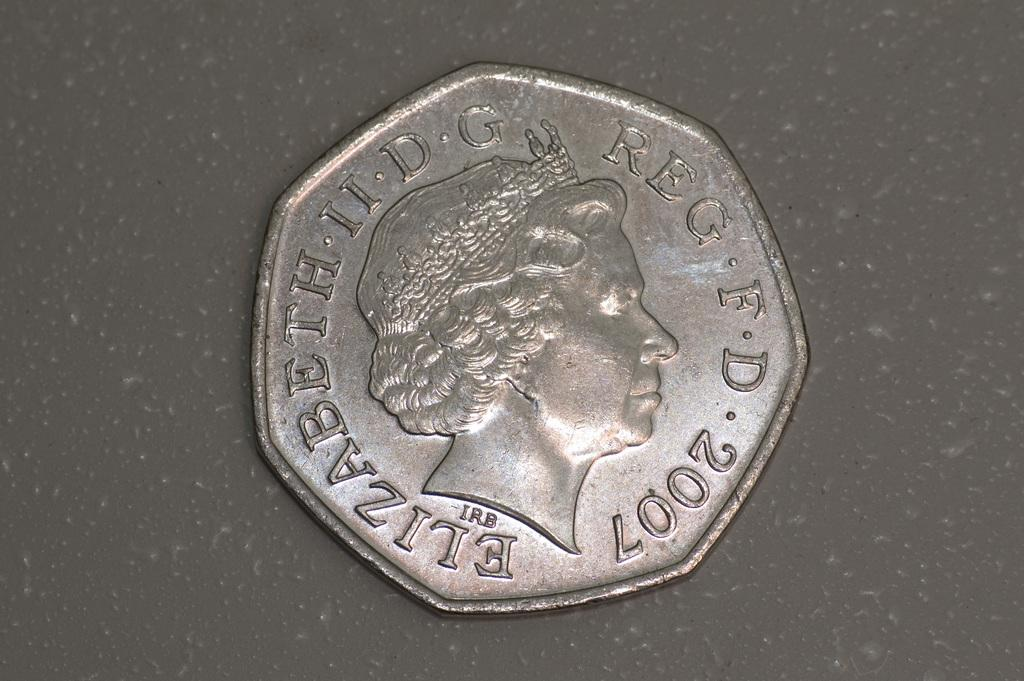<image>
Give a short and clear explanation of the subsequent image. A metallic coin from 2007 has Elizabeth II engraved on it. 